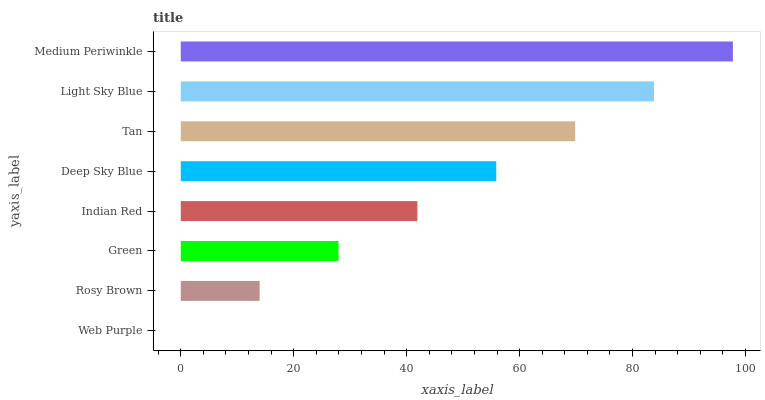Is Web Purple the minimum?
Answer yes or no. Yes. Is Medium Periwinkle the maximum?
Answer yes or no. Yes. Is Rosy Brown the minimum?
Answer yes or no. No. Is Rosy Brown the maximum?
Answer yes or no. No. Is Rosy Brown greater than Web Purple?
Answer yes or no. Yes. Is Web Purple less than Rosy Brown?
Answer yes or no. Yes. Is Web Purple greater than Rosy Brown?
Answer yes or no. No. Is Rosy Brown less than Web Purple?
Answer yes or no. No. Is Deep Sky Blue the high median?
Answer yes or no. Yes. Is Indian Red the low median?
Answer yes or no. Yes. Is Green the high median?
Answer yes or no. No. Is Tan the low median?
Answer yes or no. No. 